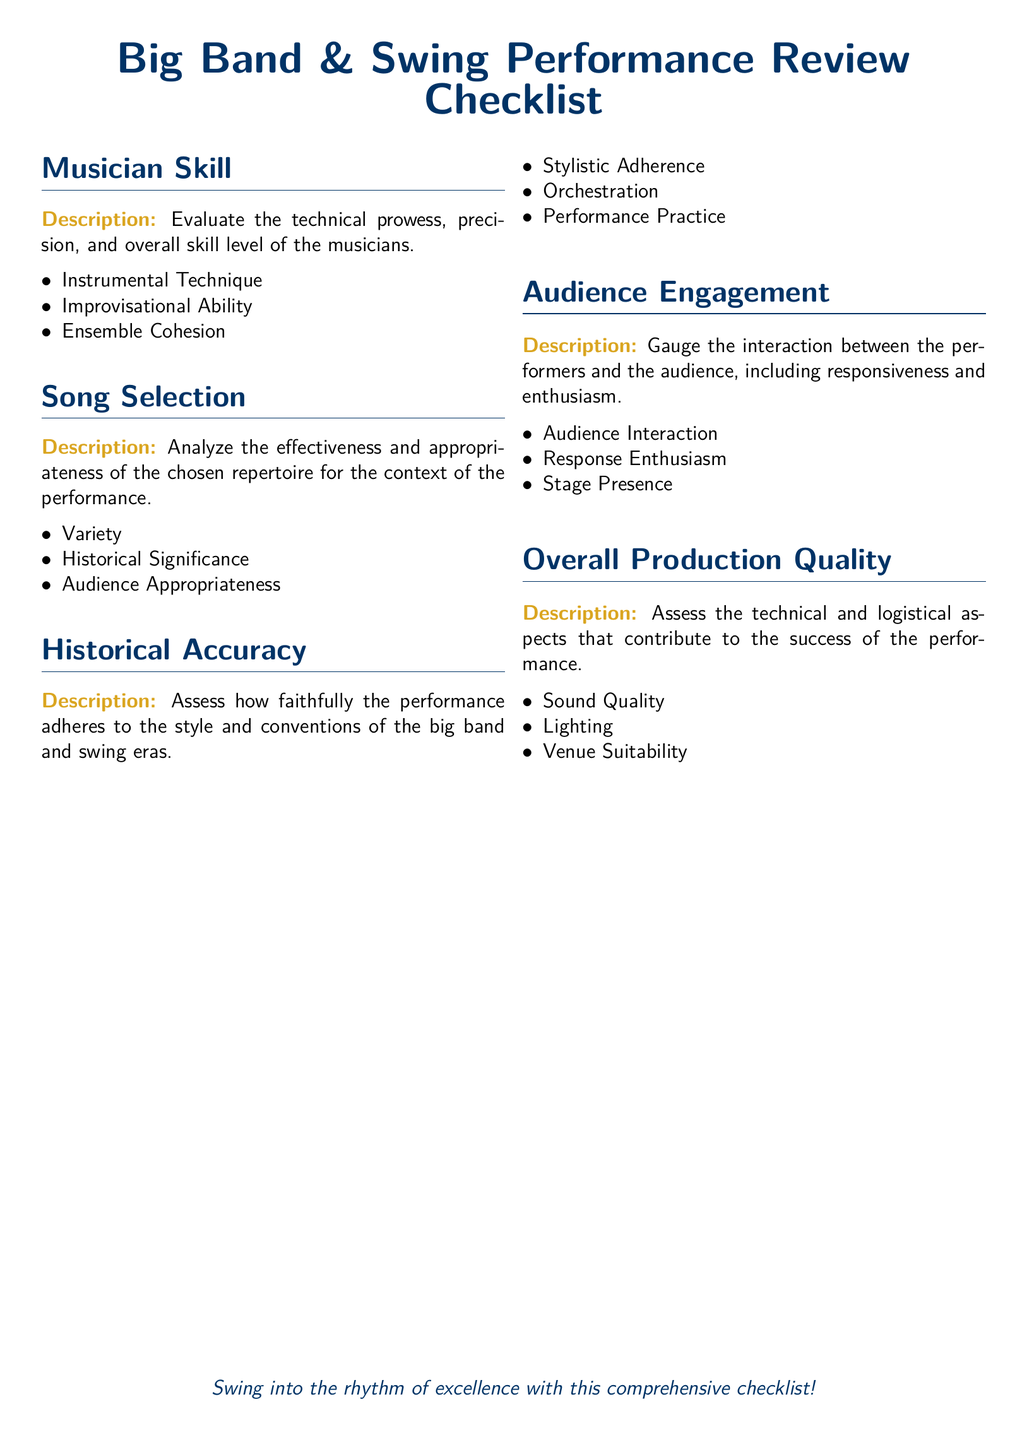What are the two main sections of the checklist? The main sections are "Musician Skill" and "Overall Production Quality," among others.
Answer: Musician Skill, Overall Production Quality How many criteria are listed under "Song Selection"? The criteria under "Song Selection" include three items: Variety, Historical Significance, and Audience Appropriateness.
Answer: 3 What aspect does "Historical Accuracy" evaluate? "Historical Accuracy" evaluates how faithfully the performance adheres to the style and conventions of the big band and swing eras.
Answer: Style and conventions Which element under "Overall Production Quality" assesses the venue? The criterion that assesses the venue is labeled "Venue Suitability."
Answer: Venue Suitability What does "Audience Engagement" measure? "Audience Engagement" measures interaction between the performers and the audience, including responsiveness and enthusiasm.
Answer: Interaction and responsiveness 